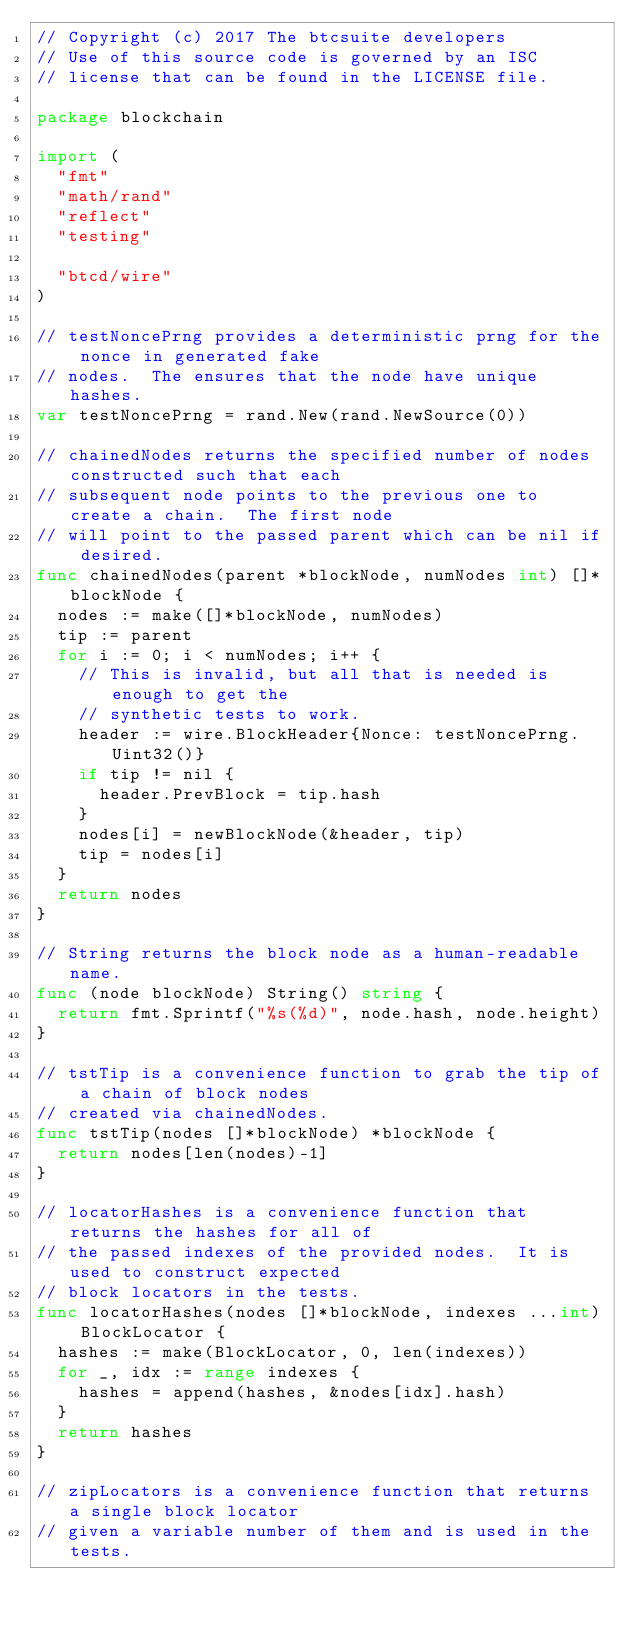Convert code to text. <code><loc_0><loc_0><loc_500><loc_500><_Go_>// Copyright (c) 2017 The btcsuite developers
// Use of this source code is governed by an ISC
// license that can be found in the LICENSE file.

package blockchain

import (
	"fmt"
	"math/rand"
	"reflect"
	"testing"

	"btcd/wire"
)

// testNoncePrng provides a deterministic prng for the nonce in generated fake
// nodes.  The ensures that the node have unique hashes.
var testNoncePrng = rand.New(rand.NewSource(0))

// chainedNodes returns the specified number of nodes constructed such that each
// subsequent node points to the previous one to create a chain.  The first node
// will point to the passed parent which can be nil if desired.
func chainedNodes(parent *blockNode, numNodes int) []*blockNode {
	nodes := make([]*blockNode, numNodes)
	tip := parent
	for i := 0; i < numNodes; i++ {
		// This is invalid, but all that is needed is enough to get the
		// synthetic tests to work.
		header := wire.BlockHeader{Nonce: testNoncePrng.Uint32()}
		if tip != nil {
			header.PrevBlock = tip.hash
		}
		nodes[i] = newBlockNode(&header, tip)
		tip = nodes[i]
	}
	return nodes
}

// String returns the block node as a human-readable name.
func (node blockNode) String() string {
	return fmt.Sprintf("%s(%d)", node.hash, node.height)
}

// tstTip is a convenience function to grab the tip of a chain of block nodes
// created via chainedNodes.
func tstTip(nodes []*blockNode) *blockNode {
	return nodes[len(nodes)-1]
}

// locatorHashes is a convenience function that returns the hashes for all of
// the passed indexes of the provided nodes.  It is used to construct expected
// block locators in the tests.
func locatorHashes(nodes []*blockNode, indexes ...int) BlockLocator {
	hashes := make(BlockLocator, 0, len(indexes))
	for _, idx := range indexes {
		hashes = append(hashes, &nodes[idx].hash)
	}
	return hashes
}

// zipLocators is a convenience function that returns a single block locator
// given a variable number of them and is used in the tests.</code> 